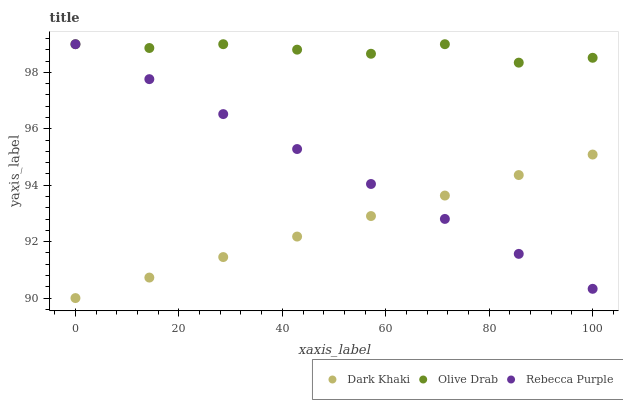Does Dark Khaki have the minimum area under the curve?
Answer yes or no. Yes. Does Olive Drab have the maximum area under the curve?
Answer yes or no. Yes. Does Rebecca Purple have the minimum area under the curve?
Answer yes or no. No. Does Rebecca Purple have the maximum area under the curve?
Answer yes or no. No. Is Dark Khaki the smoothest?
Answer yes or no. Yes. Is Olive Drab the roughest?
Answer yes or no. Yes. Is Rebecca Purple the smoothest?
Answer yes or no. No. Is Rebecca Purple the roughest?
Answer yes or no. No. Does Dark Khaki have the lowest value?
Answer yes or no. Yes. Does Rebecca Purple have the lowest value?
Answer yes or no. No. Does Olive Drab have the highest value?
Answer yes or no. Yes. Is Dark Khaki less than Olive Drab?
Answer yes or no. Yes. Is Olive Drab greater than Dark Khaki?
Answer yes or no. Yes. Does Dark Khaki intersect Rebecca Purple?
Answer yes or no. Yes. Is Dark Khaki less than Rebecca Purple?
Answer yes or no. No. Is Dark Khaki greater than Rebecca Purple?
Answer yes or no. No. Does Dark Khaki intersect Olive Drab?
Answer yes or no. No. 